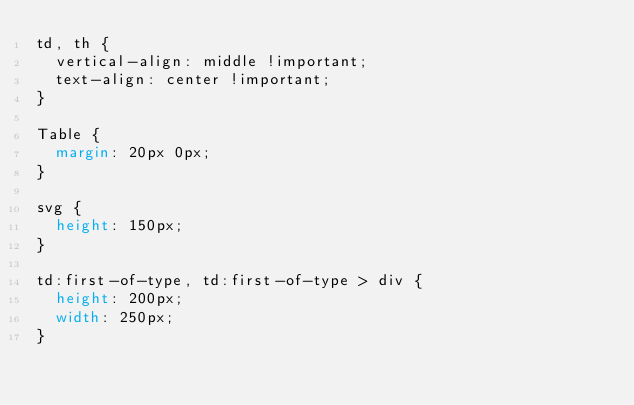<code> <loc_0><loc_0><loc_500><loc_500><_CSS_>td, th {
  vertical-align: middle !important;
  text-align: center !important;
}

Table {
  margin: 20px 0px;
}

svg {
  height: 150px;
}

td:first-of-type, td:first-of-type > div {
  height: 200px;
  width: 250px;
}
</code> 